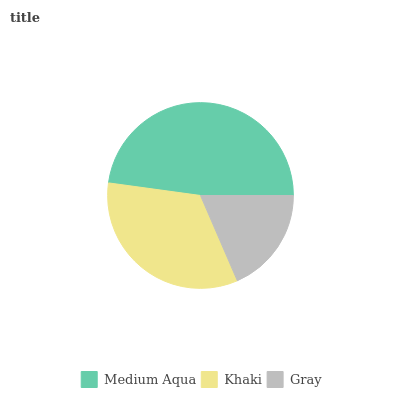Is Gray the minimum?
Answer yes or no. Yes. Is Medium Aqua the maximum?
Answer yes or no. Yes. Is Khaki the minimum?
Answer yes or no. No. Is Khaki the maximum?
Answer yes or no. No. Is Medium Aqua greater than Khaki?
Answer yes or no. Yes. Is Khaki less than Medium Aqua?
Answer yes or no. Yes. Is Khaki greater than Medium Aqua?
Answer yes or no. No. Is Medium Aqua less than Khaki?
Answer yes or no. No. Is Khaki the high median?
Answer yes or no. Yes. Is Khaki the low median?
Answer yes or no. Yes. Is Gray the high median?
Answer yes or no. No. Is Medium Aqua the low median?
Answer yes or no. No. 